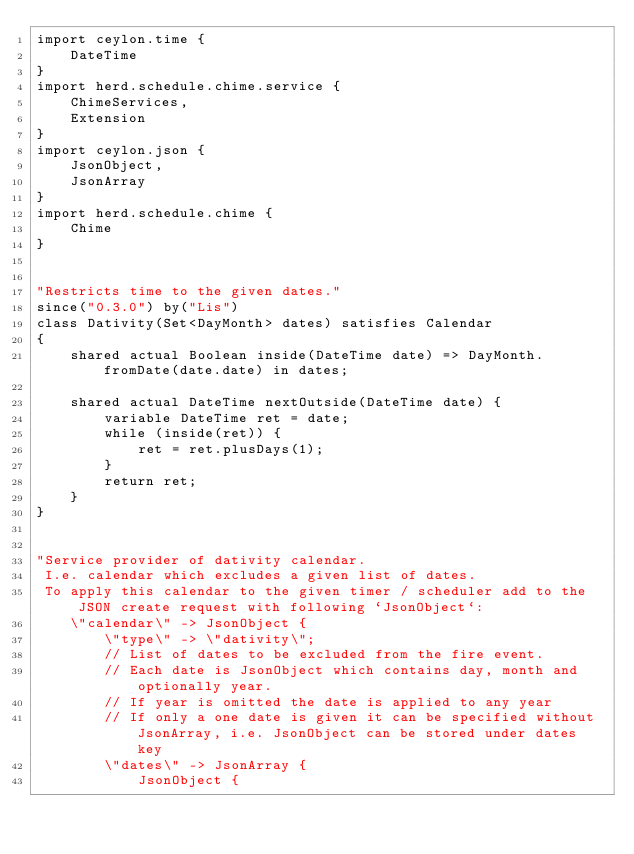Convert code to text. <code><loc_0><loc_0><loc_500><loc_500><_Ceylon_>import ceylon.time {
	DateTime
}
import herd.schedule.chime.service {
	ChimeServices,
	Extension
}
import ceylon.json {
	JsonObject,
	JsonArray
}
import herd.schedule.chime {
	Chime
}


"Restricts time to the given dates."
since("0.3.0") by("Lis")
class Dativity(Set<DayMonth> dates) satisfies Calendar 
{	
	shared actual Boolean inside(DateTime date) => DayMonth.fromDate(date.date) in dates;
	
	shared actual DateTime nextOutside(DateTime date) {
		variable DateTime ret = date;
		while (inside(ret)) {
			ret = ret.plusDays(1);
		}
		return ret;
	}	
}


"Service provider of dativity calendar.  
 I.e. calendar which excludes a given list of dates.  
 To apply this calendar to the given timer / scheduler add to the JSON create request with following `JsonObject`:
 	\"calendar\" -> JsonObject {
 		\"type\" -> \"dativity\";
 		// List of dates to be excluded from the fire event.
 		// Each date is JsonObject which contains day, month and optionally year.
 		// If year is omitted the date is applied to any year
 		// If only a one date is given it can be specified without JsonArray, i.e. JsonObject can be stored under dates key
 		\"dates\" -> JsonArray {
 			JsonObject {</code> 